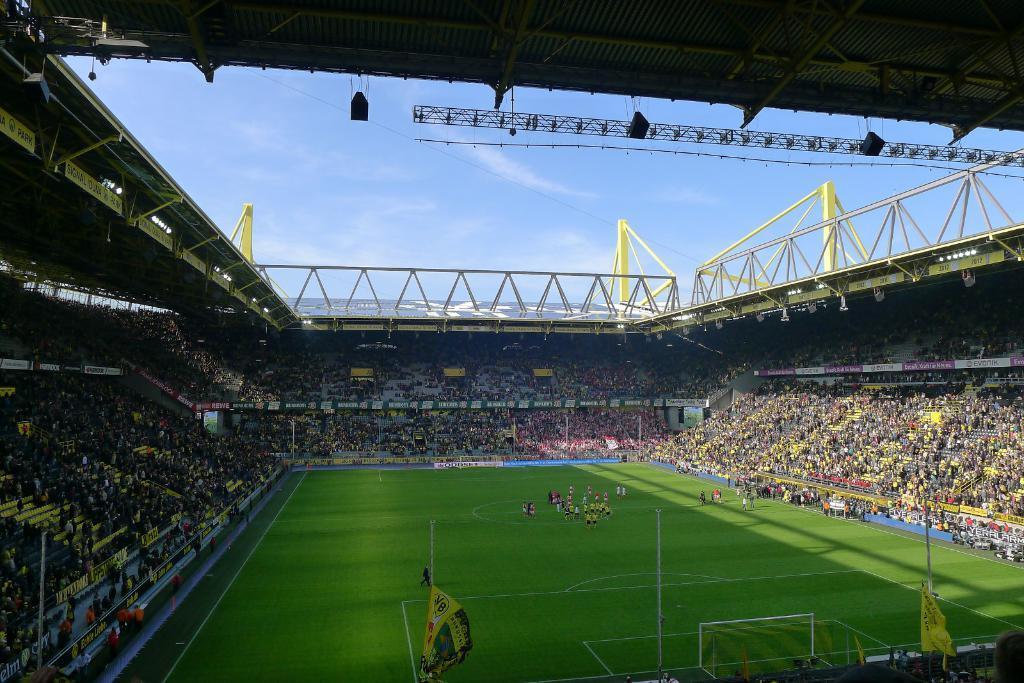Describe this image in one or two sentences. In the image there is a stadium. Inside the stadium there are many people. And on the ground there are players. At the top of the image there is a ceiling. And also there is sky. 